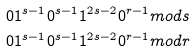<formula> <loc_0><loc_0><loc_500><loc_500>0 1 ^ { s - 1 } 0 ^ { s - 1 } 1 ^ { 2 s - 2 } 0 ^ { r - 1 } & m o d s \\ 0 1 ^ { s - 1 } 0 ^ { s - 1 } 1 ^ { 2 s - 2 } 0 ^ { r - 1 } & m o d r</formula> 